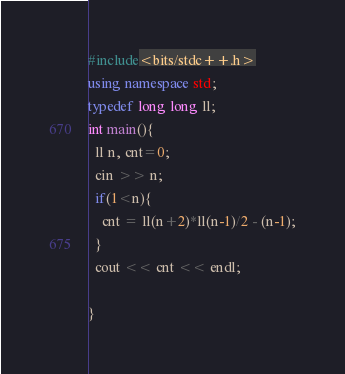<code> <loc_0><loc_0><loc_500><loc_500><_C++_>#include<bits/stdc++.h>
using namespace std;
typedef long long ll;
int main(){
  ll n, cnt=0;
  cin >> n;
  if(1<n){
    cnt = ll(n+2)*ll(n-1)/2 - (n-1);
  }
  cout << cnt << endl;

}</code> 